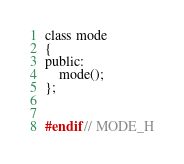<code> <loc_0><loc_0><loc_500><loc_500><_C_>class mode
{
public:
    mode();
};


#endif // MODE_H
</code> 